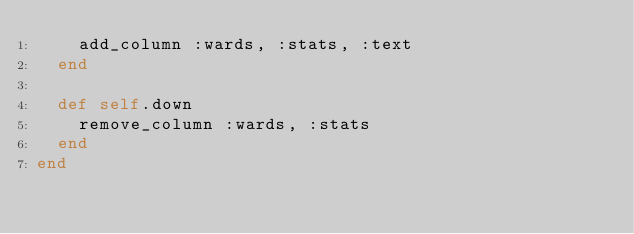<code> <loc_0><loc_0><loc_500><loc_500><_Ruby_>    add_column :wards, :stats, :text
  end

  def self.down
    remove_column :wards, :stats
  end
end
</code> 